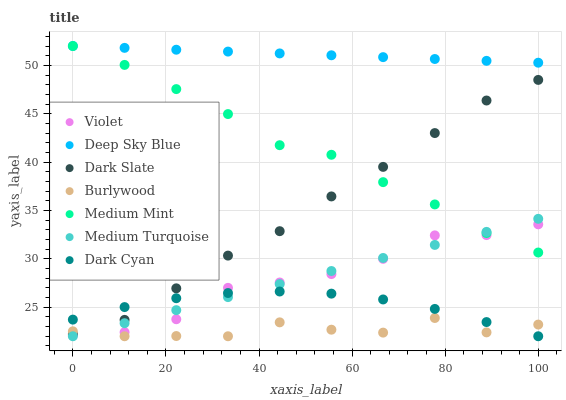Does Burlywood have the minimum area under the curve?
Answer yes or no. Yes. Does Deep Sky Blue have the maximum area under the curve?
Answer yes or no. Yes. Does Deep Sky Blue have the minimum area under the curve?
Answer yes or no. No. Does Burlywood have the maximum area under the curve?
Answer yes or no. No. Is Deep Sky Blue the smoothest?
Answer yes or no. Yes. Is Burlywood the roughest?
Answer yes or no. Yes. Is Burlywood the smoothest?
Answer yes or no. No. Is Deep Sky Blue the roughest?
Answer yes or no. No. Does Burlywood have the lowest value?
Answer yes or no. Yes. Does Deep Sky Blue have the lowest value?
Answer yes or no. No. Does Deep Sky Blue have the highest value?
Answer yes or no. Yes. Does Burlywood have the highest value?
Answer yes or no. No. Is Medium Turquoise less than Deep Sky Blue?
Answer yes or no. Yes. Is Deep Sky Blue greater than Dark Cyan?
Answer yes or no. Yes. Does Dark Slate intersect Burlywood?
Answer yes or no. Yes. Is Dark Slate less than Burlywood?
Answer yes or no. No. Is Dark Slate greater than Burlywood?
Answer yes or no. No. Does Medium Turquoise intersect Deep Sky Blue?
Answer yes or no. No. 